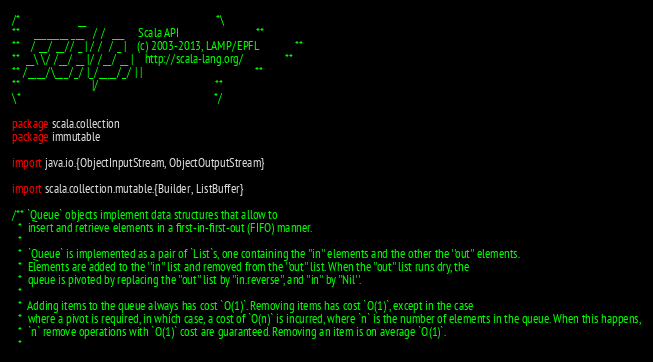Convert code to text. <code><loc_0><loc_0><loc_500><loc_500><_Scala_>/*                     __                                               *\
**     ________ ___   / /  ___     Scala API                            **
**    / __/ __// _ | / /  / _ |    (c) 2003-2013, LAMP/EPFL             **
**  __\ \/ /__/ __ |/ /__/ __ |    http://scala-lang.org/               **
** /____/\___/_/ |_/____/_/ | |                                         **
**                          |/                                          **
\*                                                                      */

package scala.collection
package immutable

import java.io.{ObjectInputStream, ObjectOutputStream}

import scala.collection.mutable.{Builder, ListBuffer}

/** `Queue` objects implement data structures that allow to
  *  insert and retrieve elements in a first-in-first-out (FIFO) manner.
  *
  *  `Queue` is implemented as a pair of `List`s, one containing the ''in'' elements and the other the ''out'' elements.
  *  Elements are added to the ''in'' list and removed from the ''out'' list. When the ''out'' list runs dry, the
  *  queue is pivoted by replacing the ''out'' list by ''in.reverse'', and ''in'' by ''Nil''.
  *
  *  Adding items to the queue always has cost `O(1)`. Removing items has cost `O(1)`, except in the case
  *  where a pivot is required, in which case, a cost of `O(n)` is incurred, where `n` is the number of elements in the queue. When this happens,
  *  `n` remove operations with `O(1)` cost are guaranteed. Removing an item is on average `O(1)`.
  *</code> 